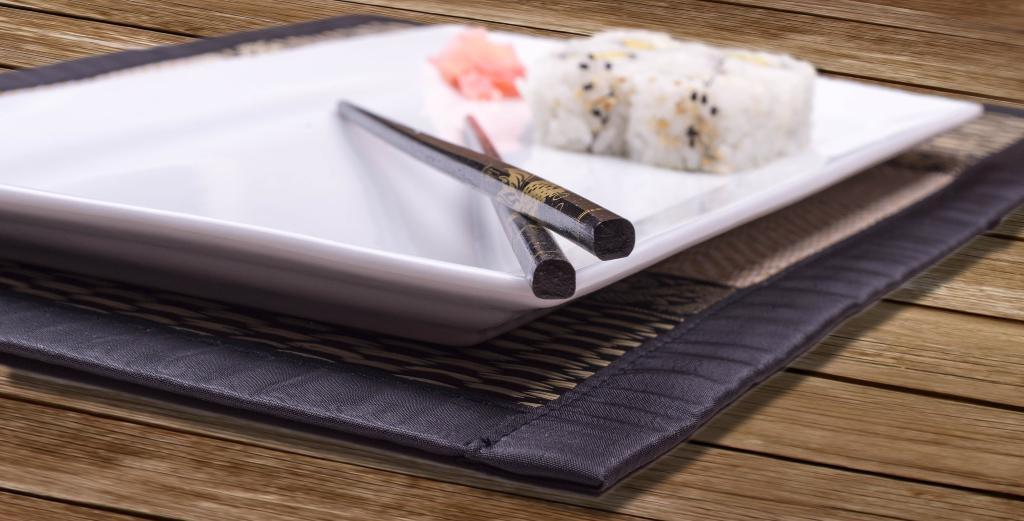What piece of furniture is present in the image? There is a table in the image. What is placed on the table? There is a tray on the table. What utensils are on the tray? There are chopsticks on the tray. What else is on the tray besides chopsticks? There is food on the tray. Where is the farm located in the image? There is no farm present in the image. What type of basket can be seen holding the food on the tray? There is no basket visible in the image; the food is directly on the tray. 